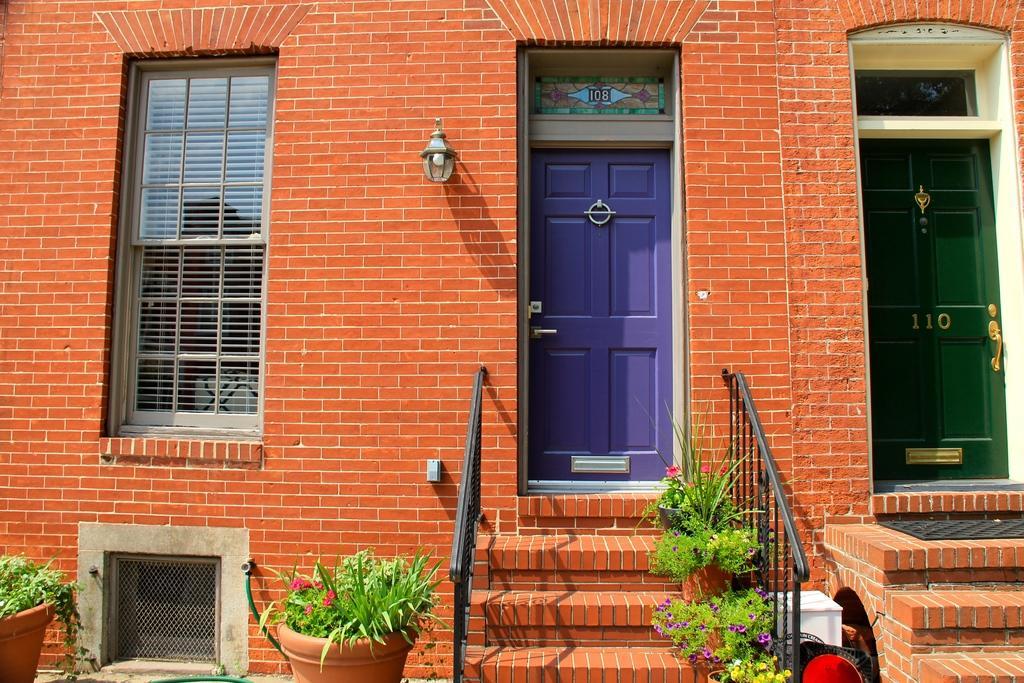Could you give a brief overview of what you see in this image? In this picture we can see a building. In the center there is a door. On the right we can see a green color door. On the left we can see window and window blind. On the bottom we can see stairs, dustbin, plants and pot. Here it's a light. 